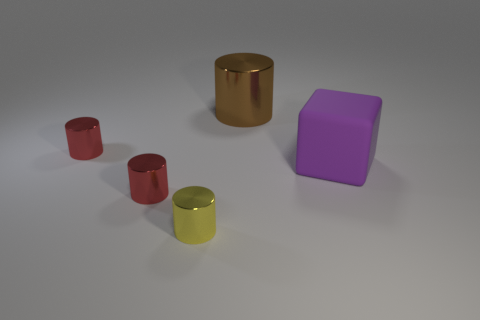Do the brown thing and the block have the same size?
Offer a very short reply. Yes. Are there an equal number of small yellow metal things that are to the left of the yellow metallic thing and tiny metal cylinders behind the large brown metal object?
Give a very brief answer. Yes. What is the shape of the big thing right of the brown metal object?
Provide a short and direct response. Cube. The other thing that is the same size as the purple rubber thing is what shape?
Ensure brevity in your answer.  Cylinder. The shiny cylinder right of the small thing in front of the small red object that is in front of the big purple matte cube is what color?
Provide a short and direct response. Brown. Is the purple rubber object the same shape as the brown thing?
Provide a succinct answer. No. Are there an equal number of brown metallic objects in front of the brown thing and big gray spheres?
Keep it short and to the point. Yes. How many other objects are there of the same material as the block?
Make the answer very short. 0. There is a object that is on the right side of the big brown object; is its size the same as the red thing in front of the large purple cube?
Offer a very short reply. No. How many objects are either metallic things that are in front of the big metallic cylinder or red objects behind the big purple block?
Offer a very short reply. 3. 